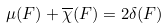<formula> <loc_0><loc_0><loc_500><loc_500>\mu ( F ) + \overline { \chi } ( F ) = 2 \delta ( F )</formula> 